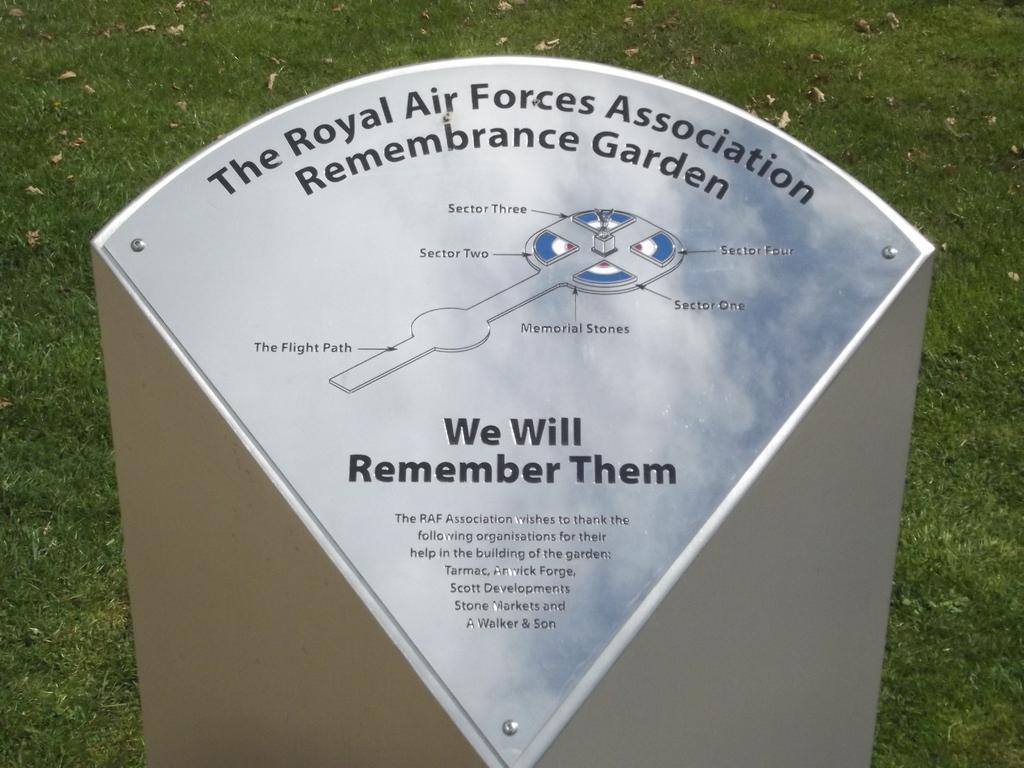In one or two sentences, can you explain what this image depicts? In this image we can see there is something written on the board. There is grass. 